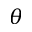<formula> <loc_0><loc_0><loc_500><loc_500>\theta</formula> 